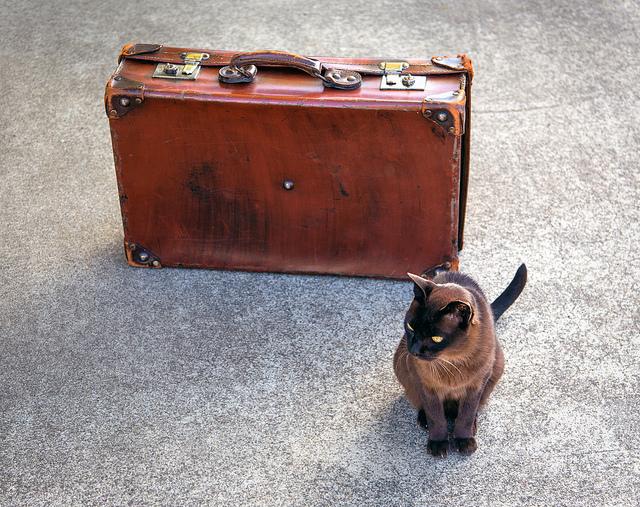Does the suitcase look beat up?
Keep it brief. Yes. Is the cat standing in front of a suitcase?
Short answer required. Yes. What color are the cat's eyes?
Answer briefly. Yellow. 